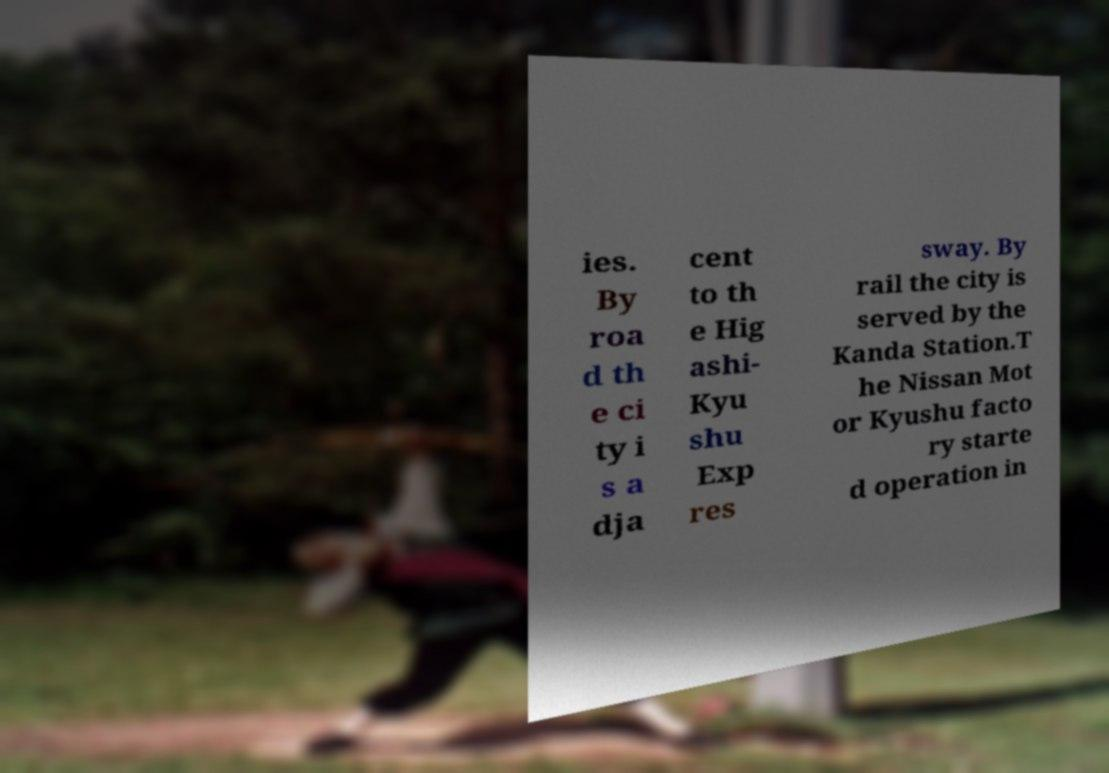For documentation purposes, I need the text within this image transcribed. Could you provide that? ies. By roa d th e ci ty i s a dja cent to th e Hig ashi- Kyu shu Exp res sway. By rail the city is served by the Kanda Station.T he Nissan Mot or Kyushu facto ry starte d operation in 